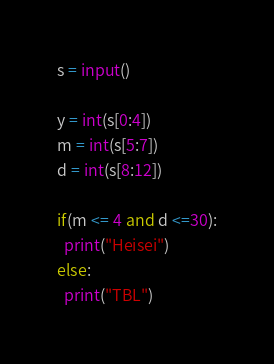Convert code to text. <code><loc_0><loc_0><loc_500><loc_500><_Python_>s = input()

y = int(s[0:4])
m = int(s[5:7])
d = int(s[8:12])

if(m <= 4 and d <=30):
  print("Heisei")
else:
  print("TBL")</code> 